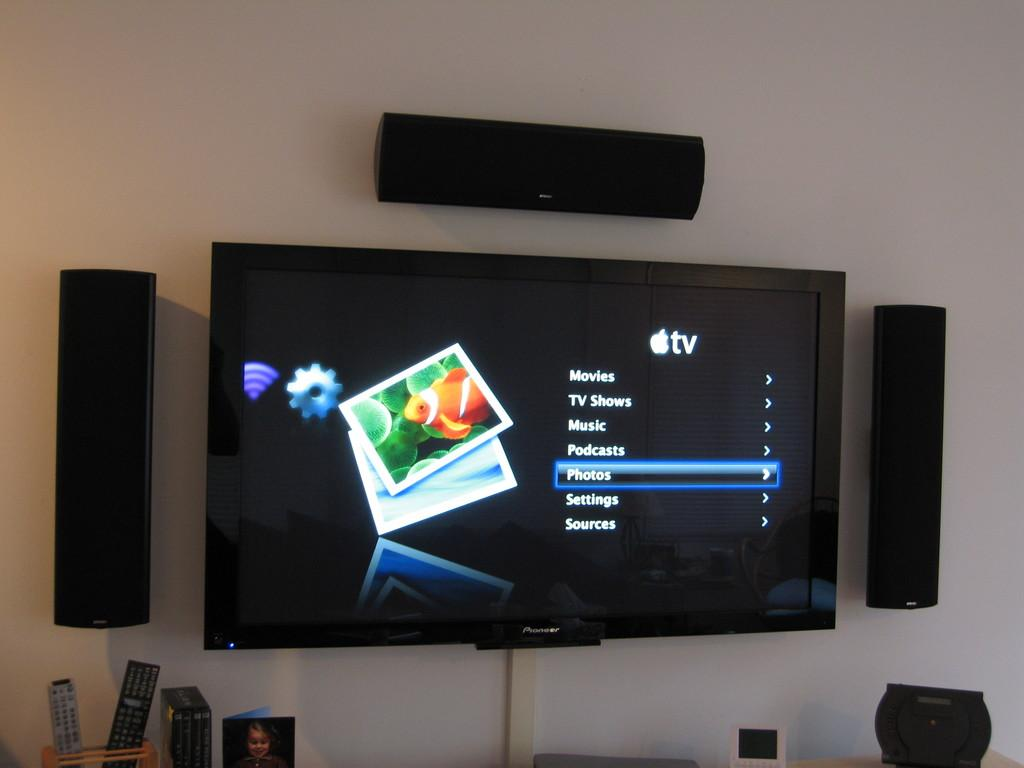<image>
Present a compact description of the photo's key features. A wall mounted TV has the words movies shows on it. 